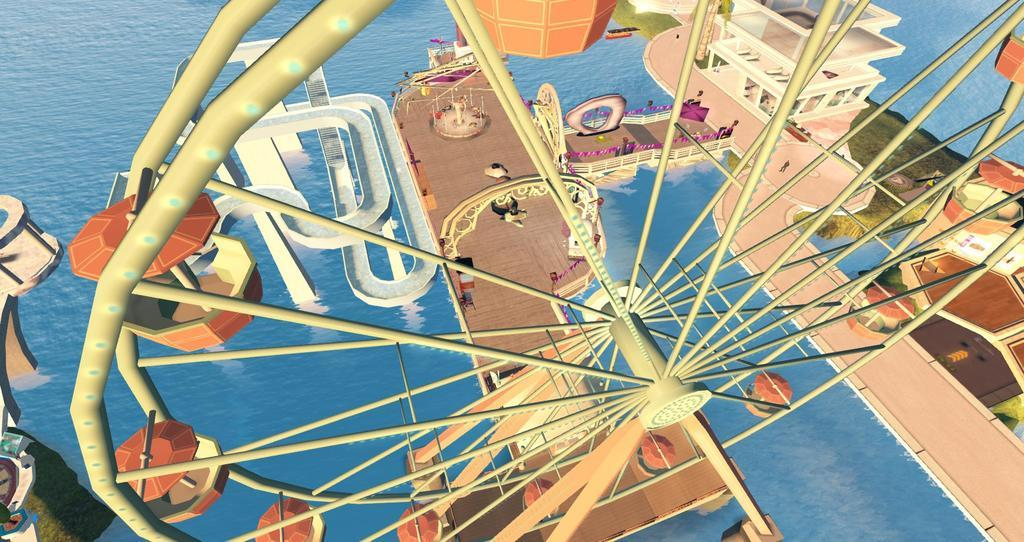What is the main subject of the animation in the image? The main subject of the animation in the image is a giant wheel. What other elements are present in the animation? There are buildings, grass, and water present in the animation. What type of division can be seen in the animation? There is no division present in the animation; it is a continuous animation of a giant wheel and its surroundings. 